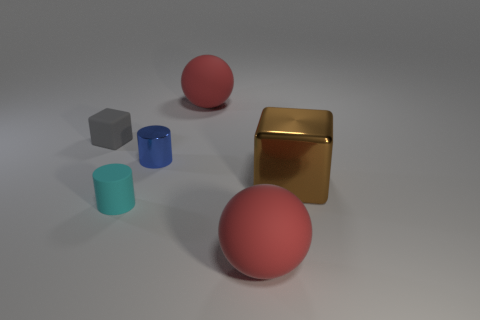Is there any other thing that is the same color as the metal block?
Give a very brief answer. No. What color is the big matte thing in front of the tiny cyan rubber cylinder?
Your answer should be compact. Red. Does the sphere behind the brown shiny object have the same color as the small metallic object?
Ensure brevity in your answer.  No. What is the material of the cyan thing that is the same shape as the small blue metallic object?
Offer a terse response. Rubber. What number of brown objects have the same size as the gray thing?
Your response must be concise. 0. What is the shape of the small cyan thing?
Your answer should be compact. Cylinder. There is a rubber thing that is both behind the tiny matte cylinder and on the right side of the gray thing; what is its size?
Your answer should be very brief. Large. What material is the big red ball that is in front of the small gray matte thing?
Ensure brevity in your answer.  Rubber. There is a big metallic cube; does it have the same color as the tiny thing in front of the brown block?
Provide a short and direct response. No. What number of objects are tiny rubber objects that are to the right of the rubber cube or red balls that are behind the brown cube?
Provide a succinct answer. 2. 